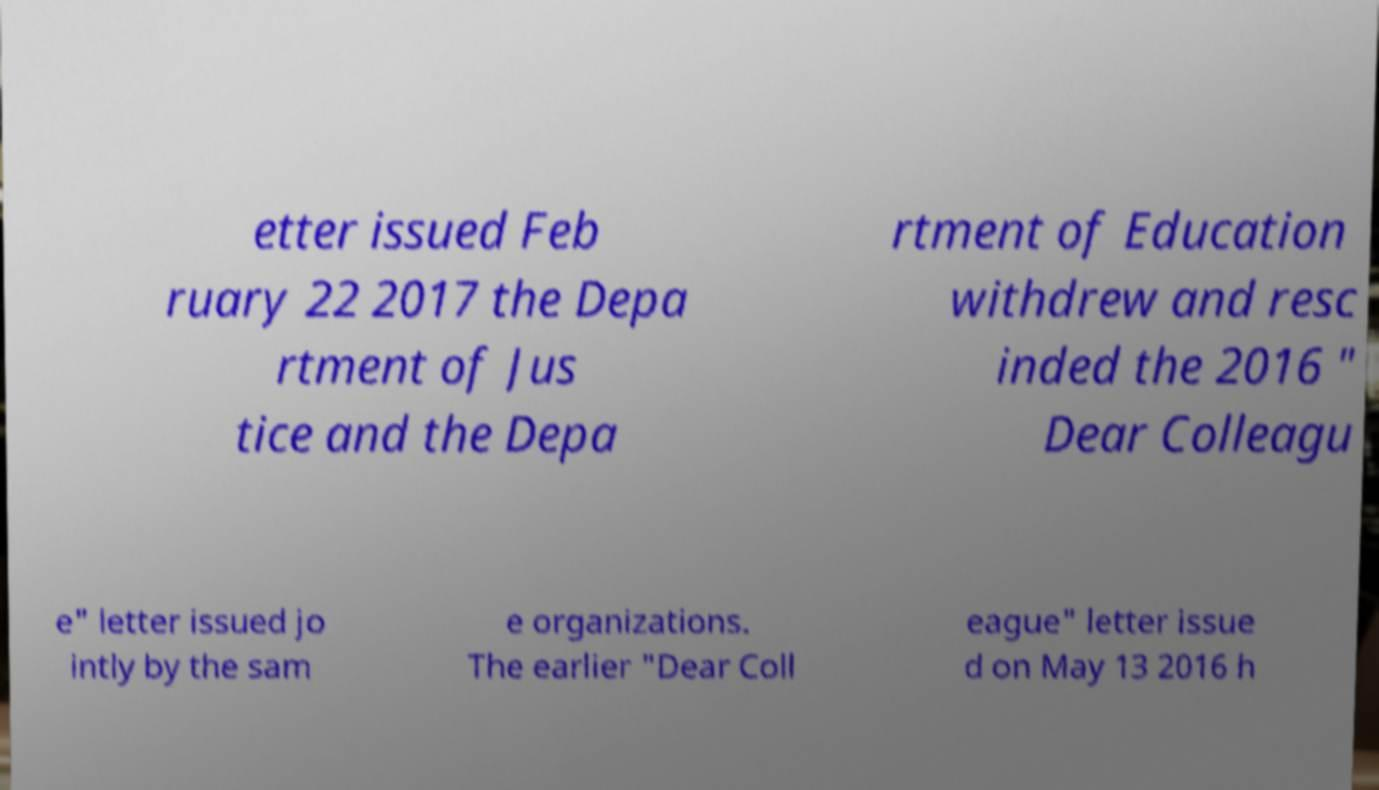Please identify and transcribe the text found in this image. etter issued Feb ruary 22 2017 the Depa rtment of Jus tice and the Depa rtment of Education withdrew and resc inded the 2016 " Dear Colleagu e" letter issued jo intly by the sam e organizations. The earlier "Dear Coll eague" letter issue d on May 13 2016 h 